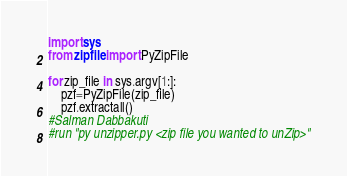<code> <loc_0><loc_0><loc_500><loc_500><_Python_>import sys
from zipfile import PyZipFile

for zip_file in sys.argv[1:]:
    pzf=PyZipFile(zip_file)
    pzf.extractall()
#Salman Dabbakuti
#run "py unzipper.py <zip file you wanted to unZip>"
</code> 